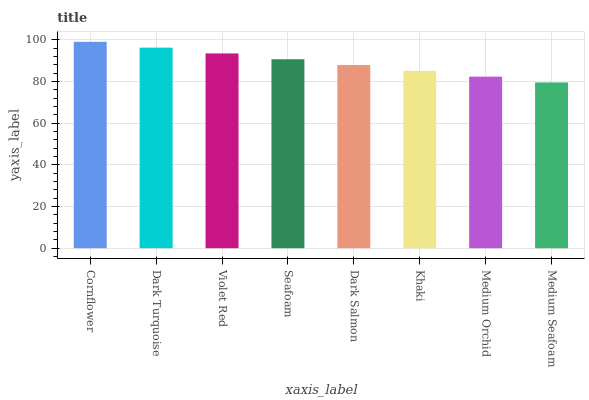Is Dark Turquoise the minimum?
Answer yes or no. No. Is Dark Turquoise the maximum?
Answer yes or no. No. Is Cornflower greater than Dark Turquoise?
Answer yes or no. Yes. Is Dark Turquoise less than Cornflower?
Answer yes or no. Yes. Is Dark Turquoise greater than Cornflower?
Answer yes or no. No. Is Cornflower less than Dark Turquoise?
Answer yes or no. No. Is Seafoam the high median?
Answer yes or no. Yes. Is Dark Salmon the low median?
Answer yes or no. Yes. Is Dark Salmon the high median?
Answer yes or no. No. Is Seafoam the low median?
Answer yes or no. No. 